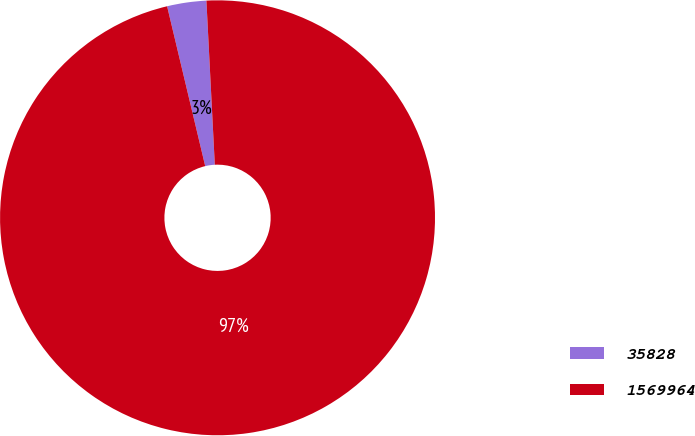Convert chart to OTSL. <chart><loc_0><loc_0><loc_500><loc_500><pie_chart><fcel>35828<fcel>1569964<nl><fcel>2.91%<fcel>97.09%<nl></chart> 